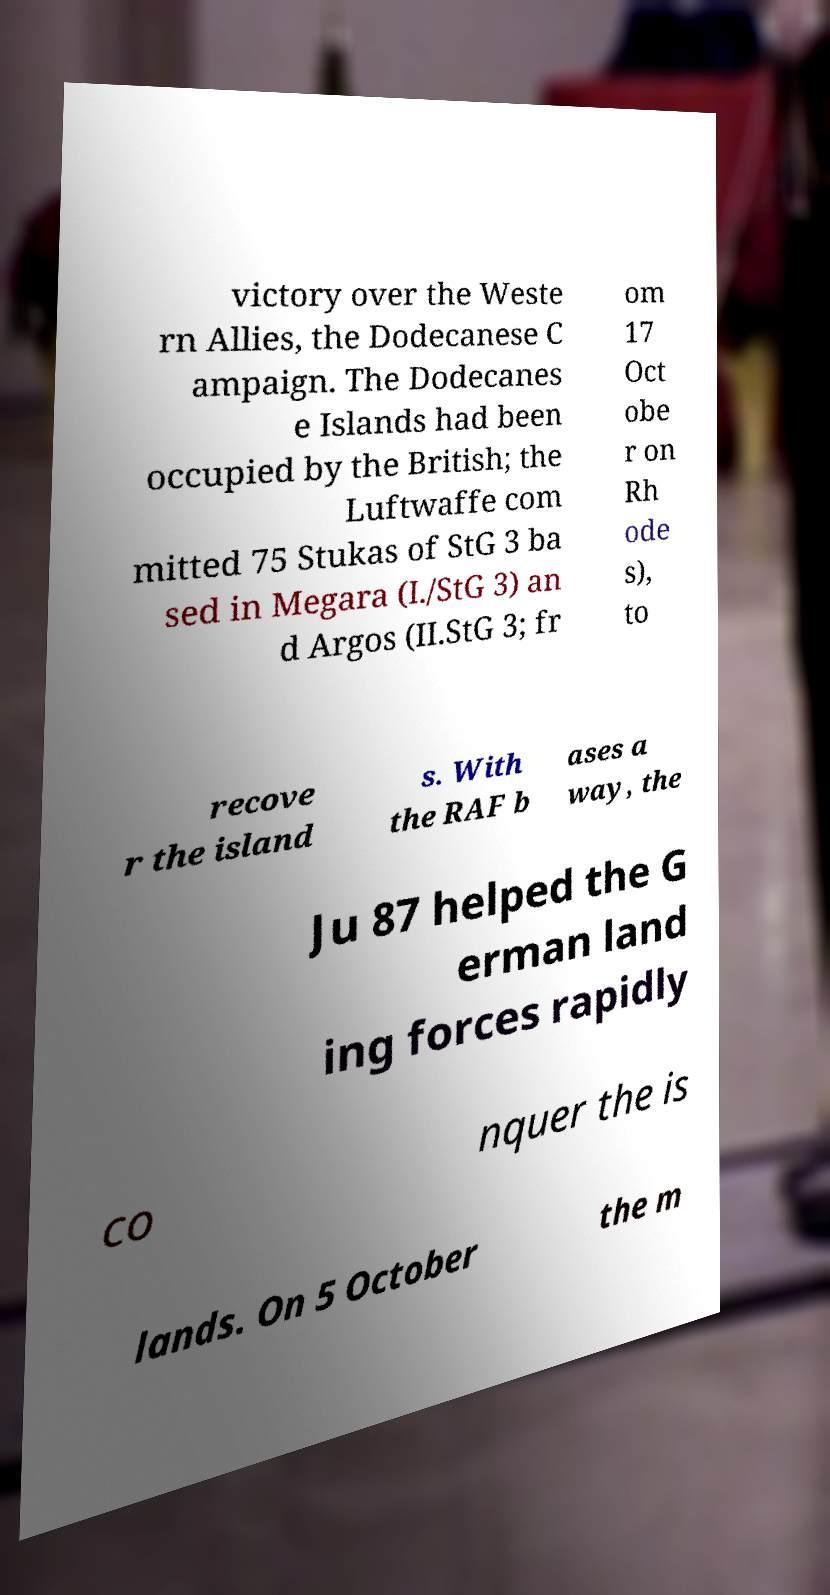For documentation purposes, I need the text within this image transcribed. Could you provide that? victory over the Weste rn Allies, the Dodecanese C ampaign. The Dodecanes e Islands had been occupied by the British; the Luftwaffe com mitted 75 Stukas of StG 3 ba sed in Megara (I./StG 3) an d Argos (II.StG 3; fr om 17 Oct obe r on Rh ode s), to recove r the island s. With the RAF b ases a way, the Ju 87 helped the G erman land ing forces rapidly co nquer the is lands. On 5 October the m 